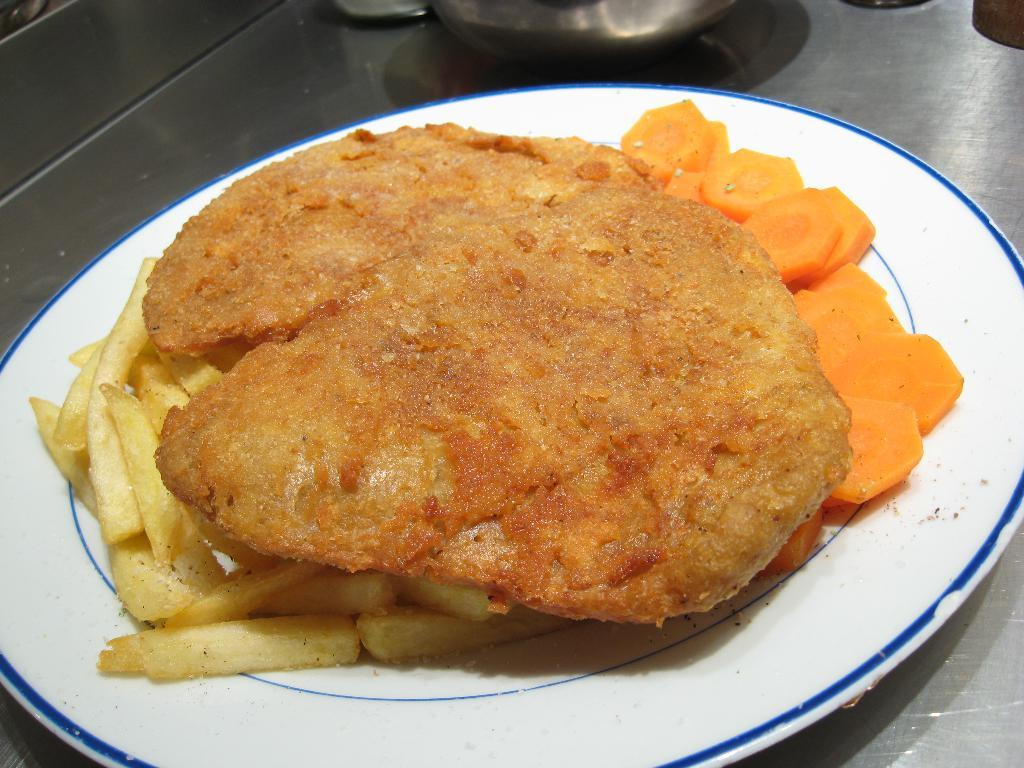What type of food items can be seen in the image? There are fried food items in the image. What other type of food items can be seen in the image? There are carrots in the image. How are the food items arranged in the image? The fried food items and carrots are placed on a plate. How many brothers are depicted eating the fried food items in the image? There are no people, including brothers, present in the image. What type of crayon is used to color the carrots in the image? There is no crayon present in the image, as the carrots are real food items. 